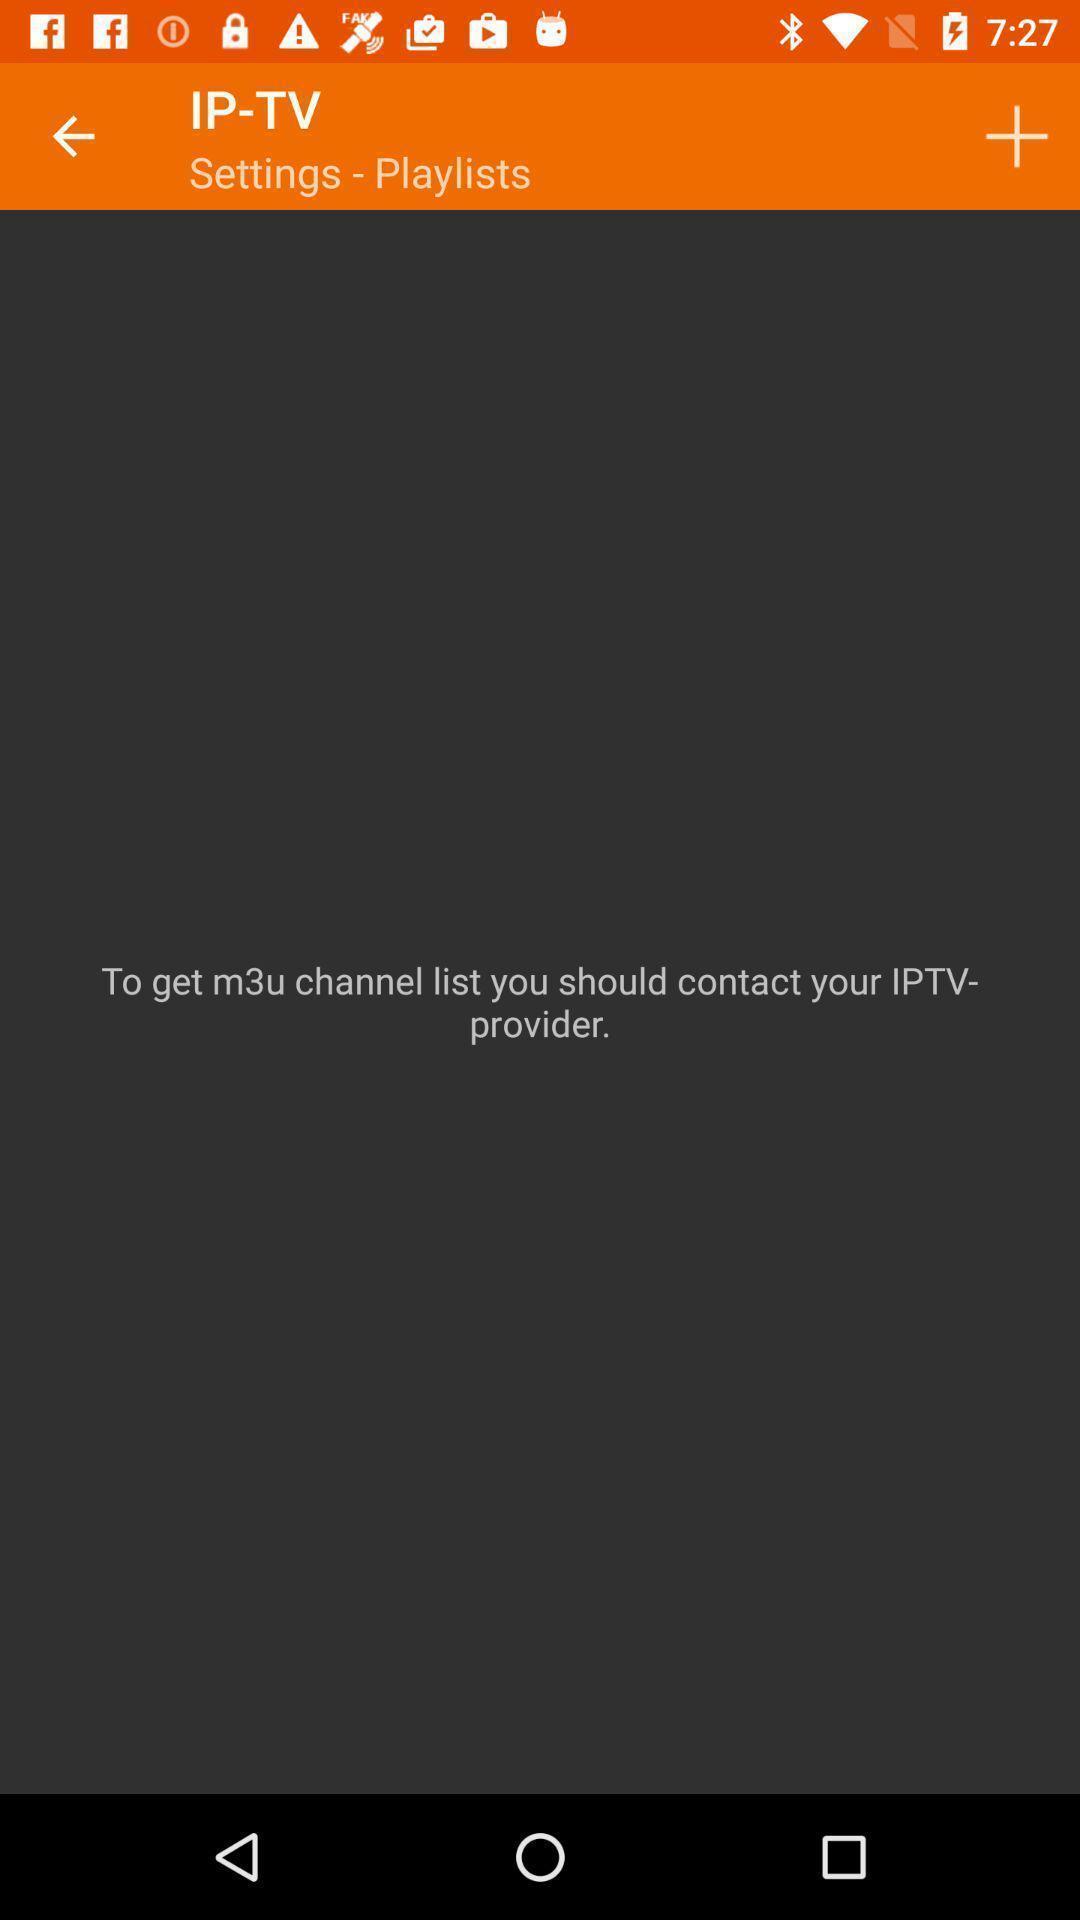Explain the elements present in this screenshot. Page showing empty playlist on app. 